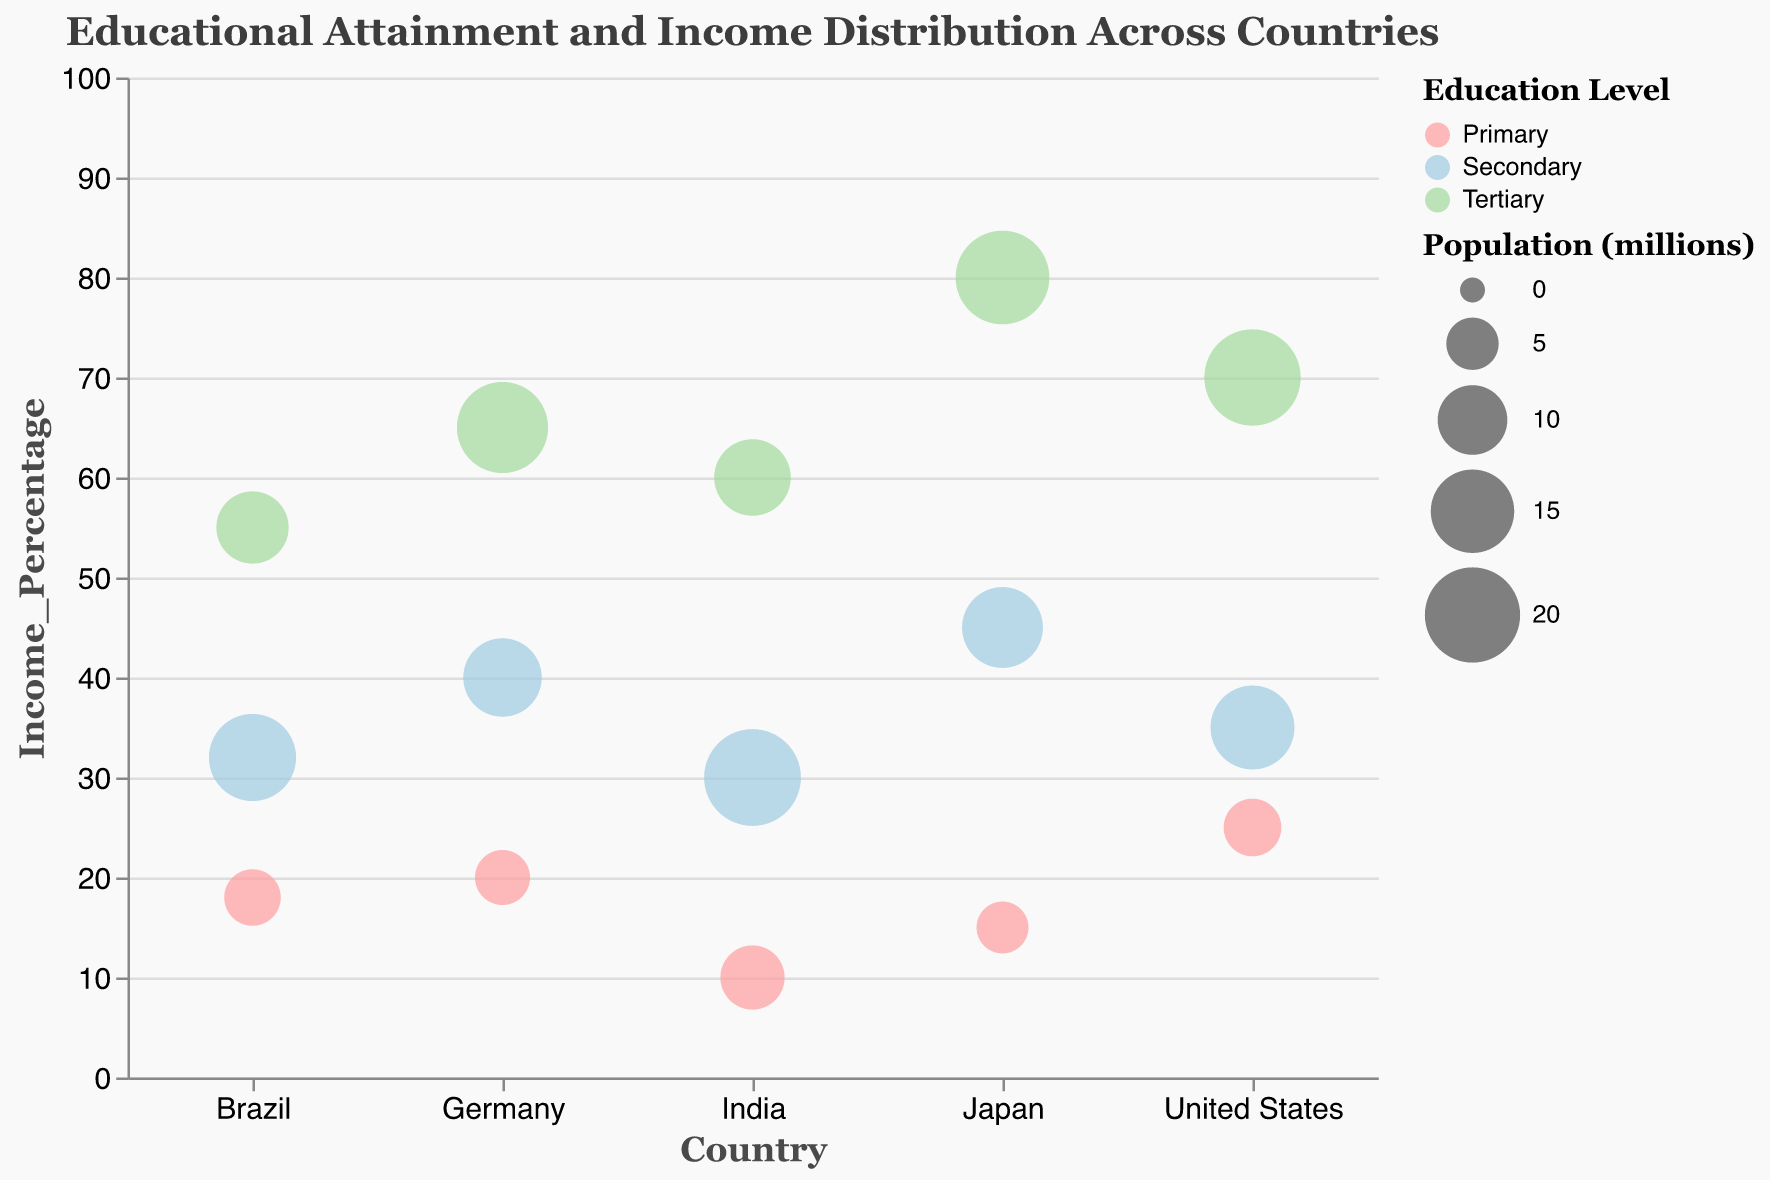What are the countries compared in the figure? The figure compares educational attainment levels and their influence on income distribution across five countries. The country names are labeled on the x-axis and include the United States, Germany, Japan, India, and Brazil.
Answer: United States, Germany, Japan, India, Brazil What is the title of the figure? The title of the figure is displayed at the top and reads "Educational Attainment and Income Distribution Across Countries."
Answer: Educational Attainment and Income Distribution Across Countries Which country has the highest income percentage for tertiary education? By looking at the highest positioned bubbles colored for tertiary education across countries, Japan has the highest income percentage for tertiary education at 80%.
Answer: Japan What is the population range used for the bubble sizes in the figure? The legend for bubble sizes indicates the population ranges from 100 to 1500 in the figure.
Answer: 100 to 1500 Compare the income percentages for primary education in the United States and India. The bubble for primary education in the United States has an income percentage of 25, while in India, it is 10. Thus, the United States has a higher income percentage for primary education compared to India.
Answer: United States has higher What is the average income percentage for tertiary education across all countries? To find the average, sum the income percentages for tertiary education in all countries: United States (70), Germany (65), Japan (80), India (60), Brazil (55). Total = 330. The average is 330/5 = 66.
Answer: 66 Which education level correlates with the largest income percentage in Brazil, and what is that percentage? The largest income percentage bubbles in Brazil can be identified by their position along the y-axis. The tertiary education level has the highest income percentage at 55%.
Answer: Tertiary, 55% Between Germany and the United States, which has a larger population for secondary education? By comparing the sizes of the bubbles for secondary education, the United States has a larger population at 15.2 million compared to Germany's 13.1 million.
Answer: United States What is the total population represented for secondary education across all countries? Add up the bubble sizes for secondary education across all countries: United States (15.2), Germany (13.1), Japan (14.0), India (20.7), Brazil (16.5). Total population = 79.5 million.
Answer: 79.5 million Which country shows the smallest income percentage for primary education, and what is that percentage? By looking at the lowest positioned bubbles colored for primary education across countries, India shows the smallest income percentage for primary education at 10%.
Answer: India, 10% 